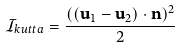Convert formula to latex. <formula><loc_0><loc_0><loc_500><loc_500>\mathcal { I } _ { k u t t a } = \frac { ( ( \mathbf u _ { 1 } - \mathbf u _ { 2 } ) \cdot \mathbf n ) ^ { 2 } } { 2 }</formula> 